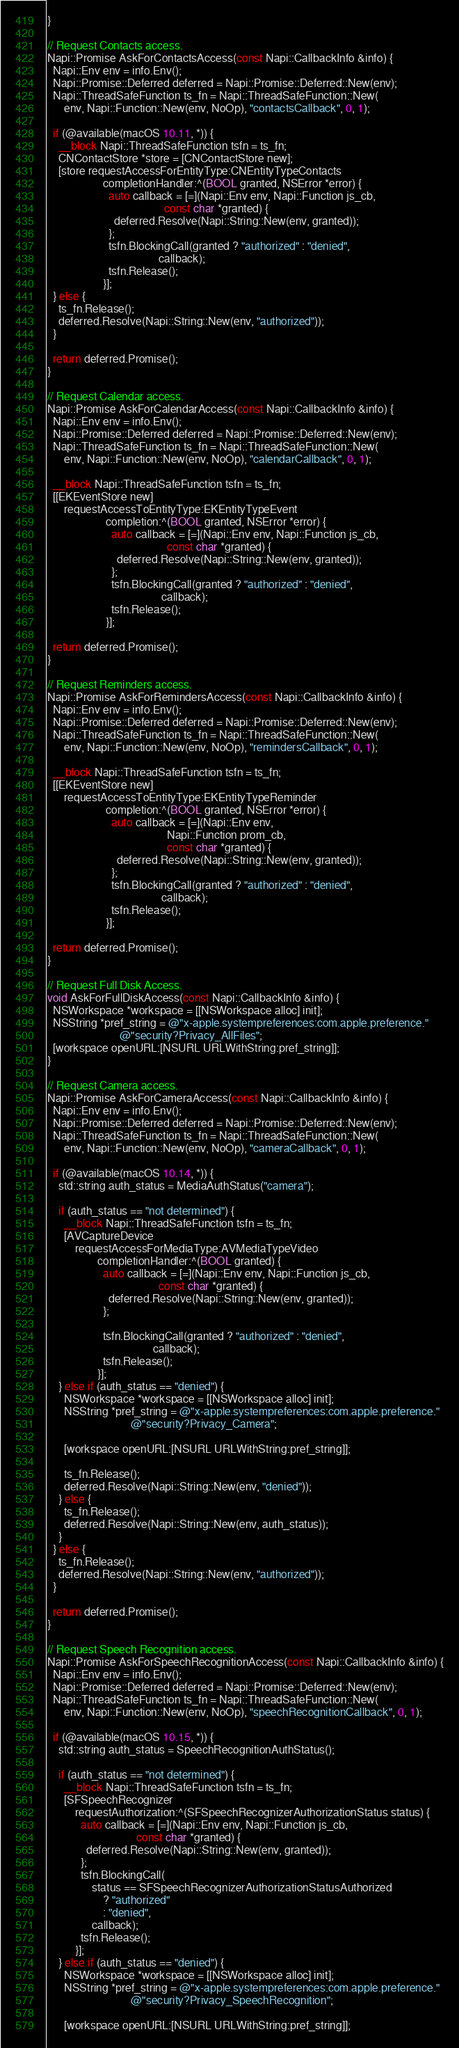<code> <loc_0><loc_0><loc_500><loc_500><_ObjectiveC_>}

// Request Contacts access.
Napi::Promise AskForContactsAccess(const Napi::CallbackInfo &info) {
  Napi::Env env = info.Env();
  Napi::Promise::Deferred deferred = Napi::Promise::Deferred::New(env);
  Napi::ThreadSafeFunction ts_fn = Napi::ThreadSafeFunction::New(
      env, Napi::Function::New(env, NoOp), "contactsCallback", 0, 1);

  if (@available(macOS 10.11, *)) {
    __block Napi::ThreadSafeFunction tsfn = ts_fn;
    CNContactStore *store = [CNContactStore new];
    [store requestAccessForEntityType:CNEntityTypeContacts
                    completionHandler:^(BOOL granted, NSError *error) {
                      auto callback = [=](Napi::Env env, Napi::Function js_cb,
                                          const char *granted) {
                        deferred.Resolve(Napi::String::New(env, granted));
                      };
                      tsfn.BlockingCall(granted ? "authorized" : "denied",
                                        callback);
                      tsfn.Release();
                    }];
  } else {
    ts_fn.Release();
    deferred.Resolve(Napi::String::New(env, "authorized"));
  }

  return deferred.Promise();
}

// Request Calendar access.
Napi::Promise AskForCalendarAccess(const Napi::CallbackInfo &info) {
  Napi::Env env = info.Env();
  Napi::Promise::Deferred deferred = Napi::Promise::Deferred::New(env);
  Napi::ThreadSafeFunction ts_fn = Napi::ThreadSafeFunction::New(
      env, Napi::Function::New(env, NoOp), "calendarCallback", 0, 1);

  __block Napi::ThreadSafeFunction tsfn = ts_fn;
  [[EKEventStore new]
      requestAccessToEntityType:EKEntityTypeEvent
                     completion:^(BOOL granted, NSError *error) {
                       auto callback = [=](Napi::Env env, Napi::Function js_cb,
                                           const char *granted) {
                         deferred.Resolve(Napi::String::New(env, granted));
                       };
                       tsfn.BlockingCall(granted ? "authorized" : "denied",
                                         callback);
                       tsfn.Release();
                     }];

  return deferred.Promise();
}

// Request Reminders access.
Napi::Promise AskForRemindersAccess(const Napi::CallbackInfo &info) {
  Napi::Env env = info.Env();
  Napi::Promise::Deferred deferred = Napi::Promise::Deferred::New(env);
  Napi::ThreadSafeFunction ts_fn = Napi::ThreadSafeFunction::New(
      env, Napi::Function::New(env, NoOp), "remindersCallback", 0, 1);

  __block Napi::ThreadSafeFunction tsfn = ts_fn;
  [[EKEventStore new]
      requestAccessToEntityType:EKEntityTypeReminder
                     completion:^(BOOL granted, NSError *error) {
                       auto callback = [=](Napi::Env env,
                                           Napi::Function prom_cb,
                                           const char *granted) {
                         deferred.Resolve(Napi::String::New(env, granted));
                       };
                       tsfn.BlockingCall(granted ? "authorized" : "denied",
                                         callback);
                       tsfn.Release();
                     }];

  return deferred.Promise();
}

// Request Full Disk Access.
void AskForFullDiskAccess(const Napi::CallbackInfo &info) {
  NSWorkspace *workspace = [[NSWorkspace alloc] init];
  NSString *pref_string = @"x-apple.systempreferences:com.apple.preference."
                          @"security?Privacy_AllFiles";
  [workspace openURL:[NSURL URLWithString:pref_string]];
}

// Request Camera access.
Napi::Promise AskForCameraAccess(const Napi::CallbackInfo &info) {
  Napi::Env env = info.Env();
  Napi::Promise::Deferred deferred = Napi::Promise::Deferred::New(env);
  Napi::ThreadSafeFunction ts_fn = Napi::ThreadSafeFunction::New(
      env, Napi::Function::New(env, NoOp), "cameraCallback", 0, 1);

  if (@available(macOS 10.14, *)) {
    std::string auth_status = MediaAuthStatus("camera");

    if (auth_status == "not determined") {
      __block Napi::ThreadSafeFunction tsfn = ts_fn;
      [AVCaptureDevice
          requestAccessForMediaType:AVMediaTypeVideo
                  completionHandler:^(BOOL granted) {
                    auto callback = [=](Napi::Env env, Napi::Function js_cb,
                                        const char *granted) {
                      deferred.Resolve(Napi::String::New(env, granted));
                    };

                    tsfn.BlockingCall(granted ? "authorized" : "denied",
                                      callback);
                    tsfn.Release();
                  }];
    } else if (auth_status == "denied") {
      NSWorkspace *workspace = [[NSWorkspace alloc] init];
      NSString *pref_string = @"x-apple.systempreferences:com.apple.preference."
                              @"security?Privacy_Camera";

      [workspace openURL:[NSURL URLWithString:pref_string]];

      ts_fn.Release();
      deferred.Resolve(Napi::String::New(env, "denied"));
    } else {
      ts_fn.Release();
      deferred.Resolve(Napi::String::New(env, auth_status));
    }
  } else {
    ts_fn.Release();
    deferred.Resolve(Napi::String::New(env, "authorized"));
  }

  return deferred.Promise();
}

// Request Speech Recognition access.
Napi::Promise AskForSpeechRecognitionAccess(const Napi::CallbackInfo &info) {
  Napi::Env env = info.Env();
  Napi::Promise::Deferred deferred = Napi::Promise::Deferred::New(env);
  Napi::ThreadSafeFunction ts_fn = Napi::ThreadSafeFunction::New(
      env, Napi::Function::New(env, NoOp), "speechRecognitionCallback", 0, 1);

  if (@available(macOS 10.15, *)) {
    std::string auth_status = SpeechRecognitionAuthStatus();

    if (auth_status == "not determined") {
      __block Napi::ThreadSafeFunction tsfn = ts_fn;
      [SFSpeechRecognizer
          requestAuthorization:^(SFSpeechRecognizerAuthorizationStatus status) {
            auto callback = [=](Napi::Env env, Napi::Function js_cb,
                                const char *granted) {
              deferred.Resolve(Napi::String::New(env, granted));
            };
            tsfn.BlockingCall(
                status == SFSpeechRecognizerAuthorizationStatusAuthorized
                    ? "authorized"
                    : "denied",
                callback);
            tsfn.Release();
          }];
    } else if (auth_status == "denied") {
      NSWorkspace *workspace = [[NSWorkspace alloc] init];
      NSString *pref_string = @"x-apple.systempreferences:com.apple.preference."
                              @"security?Privacy_SpeechRecognition";

      [workspace openURL:[NSURL URLWithString:pref_string]];
</code> 